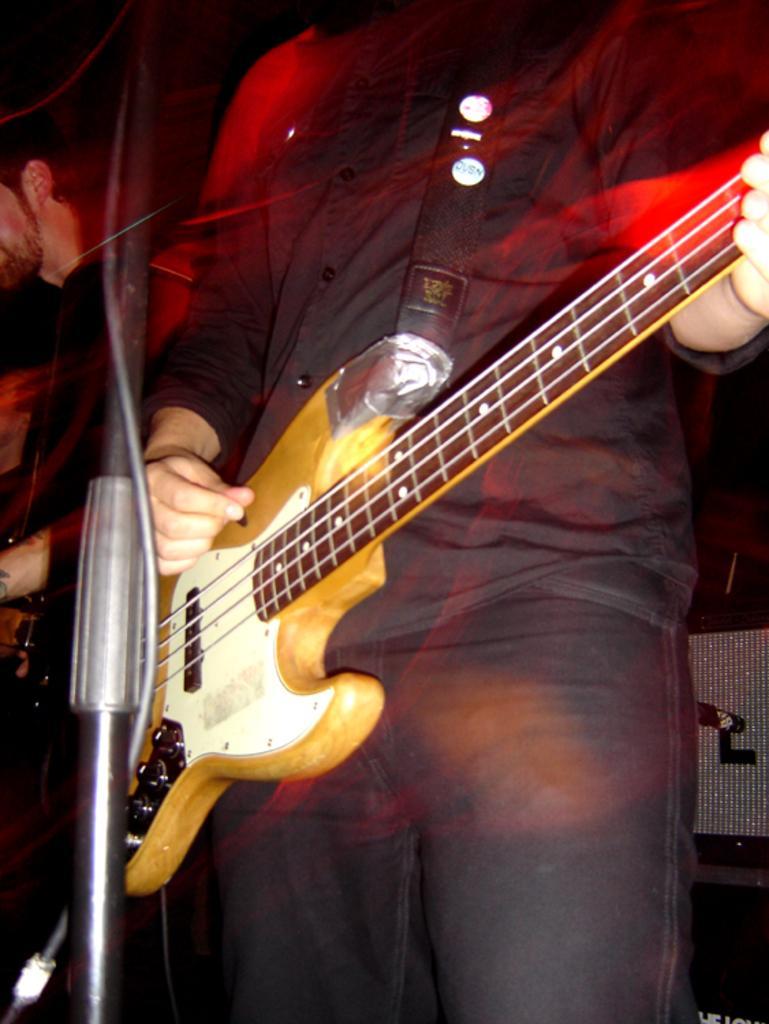Describe this image in one or two sentences. In the image in the center we can see one person standing and playing guitar. In front of him,we can see stand. In the background there is a wall and one person standing. 